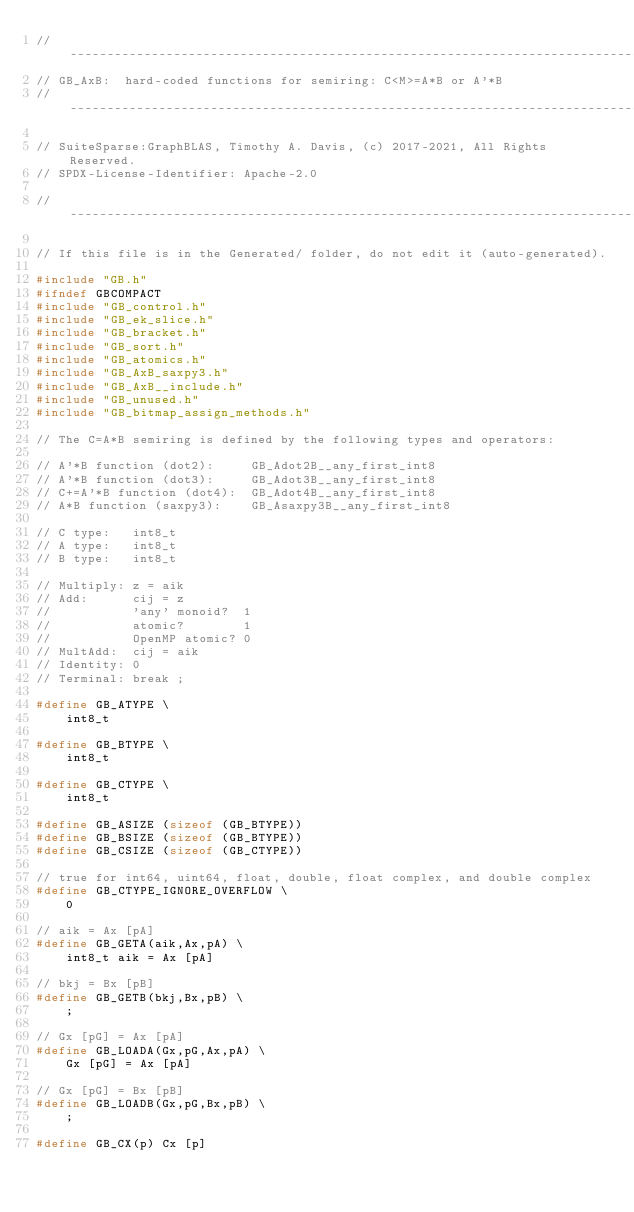<code> <loc_0><loc_0><loc_500><loc_500><_C_>//------------------------------------------------------------------------------
// GB_AxB:  hard-coded functions for semiring: C<M>=A*B or A'*B
//------------------------------------------------------------------------------

// SuiteSparse:GraphBLAS, Timothy A. Davis, (c) 2017-2021, All Rights Reserved.
// SPDX-License-Identifier: Apache-2.0

//------------------------------------------------------------------------------

// If this file is in the Generated/ folder, do not edit it (auto-generated).

#include "GB.h"
#ifndef GBCOMPACT
#include "GB_control.h"
#include "GB_ek_slice.h"
#include "GB_bracket.h"
#include "GB_sort.h"
#include "GB_atomics.h"
#include "GB_AxB_saxpy3.h"
#include "GB_AxB__include.h"
#include "GB_unused.h"
#include "GB_bitmap_assign_methods.h"

// The C=A*B semiring is defined by the following types and operators:

// A'*B function (dot2):     GB_Adot2B__any_first_int8
// A'*B function (dot3):     GB_Adot3B__any_first_int8
// C+=A'*B function (dot4):  GB_Adot4B__any_first_int8
// A*B function (saxpy3):    GB_Asaxpy3B__any_first_int8

// C type:   int8_t
// A type:   int8_t
// B type:   int8_t

// Multiply: z = aik
// Add:      cij = z
//           'any' monoid?  1
//           atomic?        1
//           OpenMP atomic? 0
// MultAdd:  cij = aik
// Identity: 0
// Terminal: break ;

#define GB_ATYPE \
    int8_t

#define GB_BTYPE \
    int8_t

#define GB_CTYPE \
    int8_t

#define GB_ASIZE (sizeof (GB_BTYPE))
#define GB_BSIZE (sizeof (GB_BTYPE))
#define GB_CSIZE (sizeof (GB_CTYPE))

// true for int64, uint64, float, double, float complex, and double complex 
#define GB_CTYPE_IGNORE_OVERFLOW \
    0

// aik = Ax [pA]
#define GB_GETA(aik,Ax,pA) \
    int8_t aik = Ax [pA]

// bkj = Bx [pB]
#define GB_GETB(bkj,Bx,pB) \
    ;

// Gx [pG] = Ax [pA]
#define GB_LOADA(Gx,pG,Ax,pA) \
    Gx [pG] = Ax [pA]

// Gx [pG] = Bx [pB]
#define GB_LOADB(Gx,pG,Bx,pB) \
    ;

#define GB_CX(p) Cx [p]
</code> 